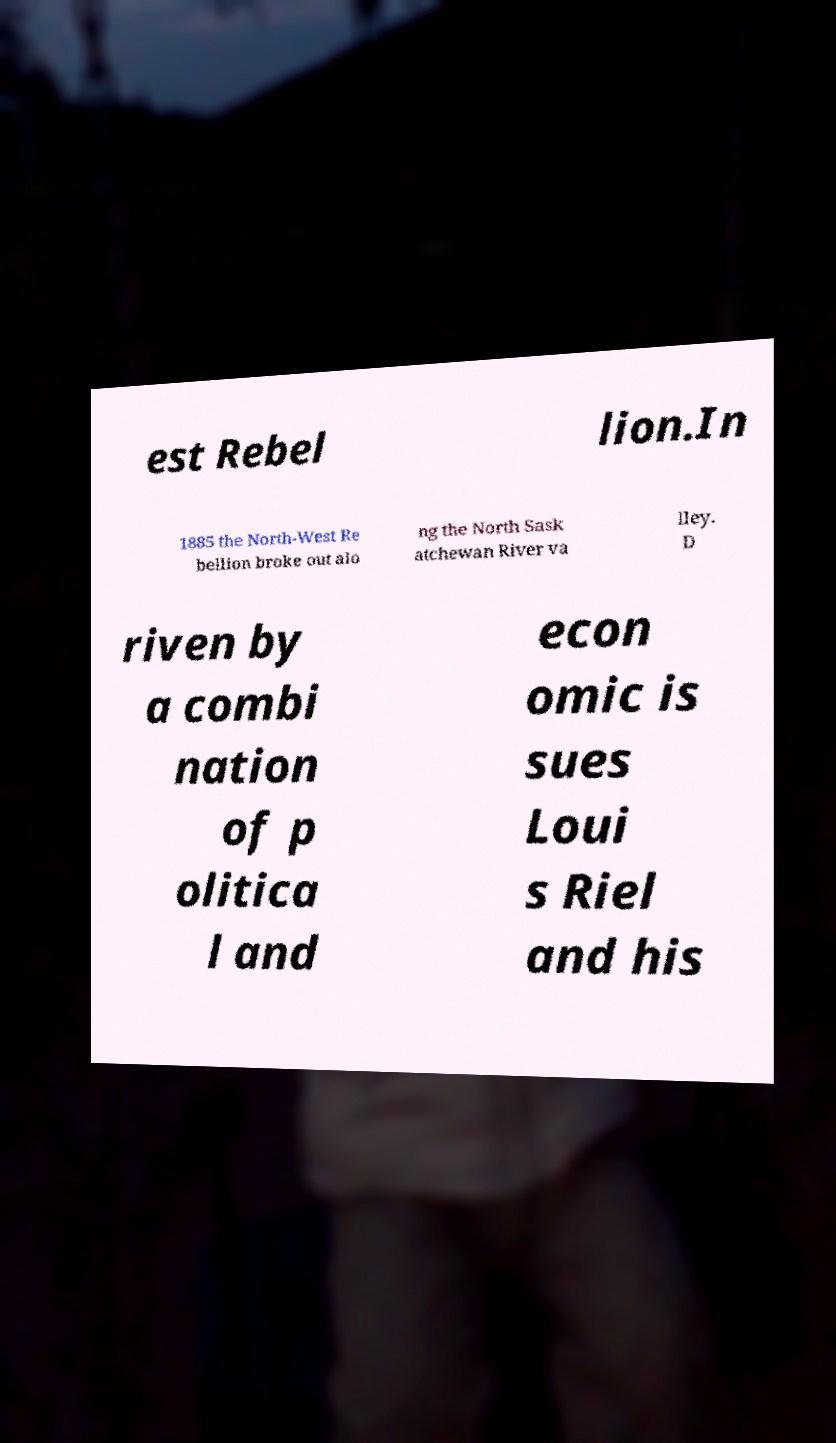What messages or text are displayed in this image? I need them in a readable, typed format. est Rebel lion.In 1885 the North-West Re bellion broke out alo ng the North Sask atchewan River va lley. D riven by a combi nation of p olitica l and econ omic is sues Loui s Riel and his 